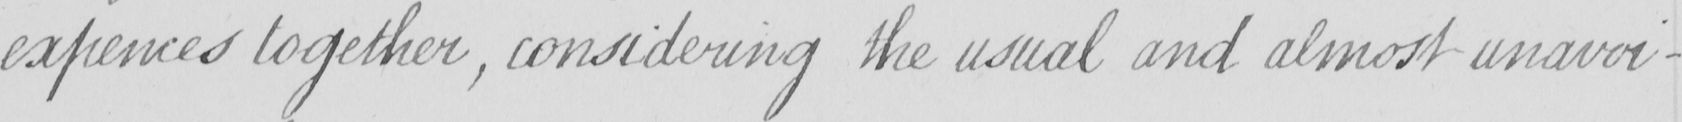Can you read and transcribe this handwriting? expences together  , considering the usual and almost unavoi- 